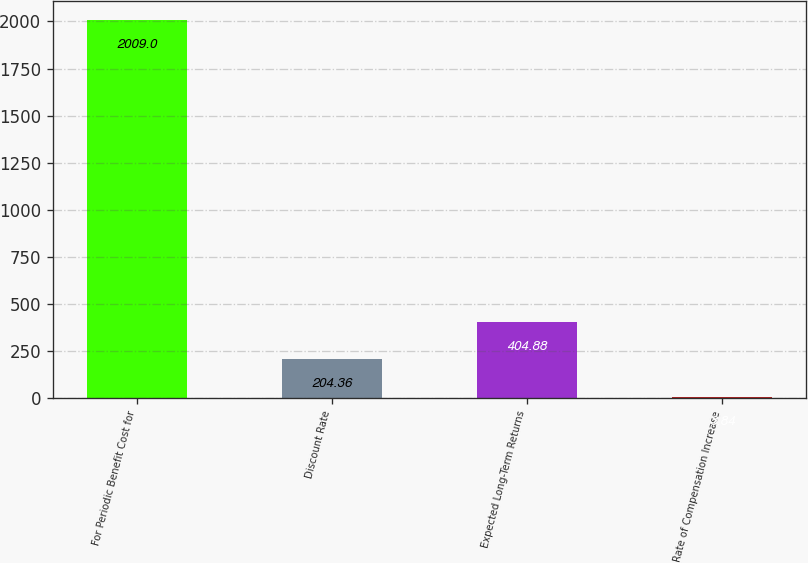Convert chart. <chart><loc_0><loc_0><loc_500><loc_500><bar_chart><fcel>For Periodic Benefit Cost for<fcel>Discount Rate<fcel>Expected Long-Term Returns<fcel>Rate of Compensation Increase<nl><fcel>2009<fcel>204.36<fcel>404.88<fcel>3.84<nl></chart> 